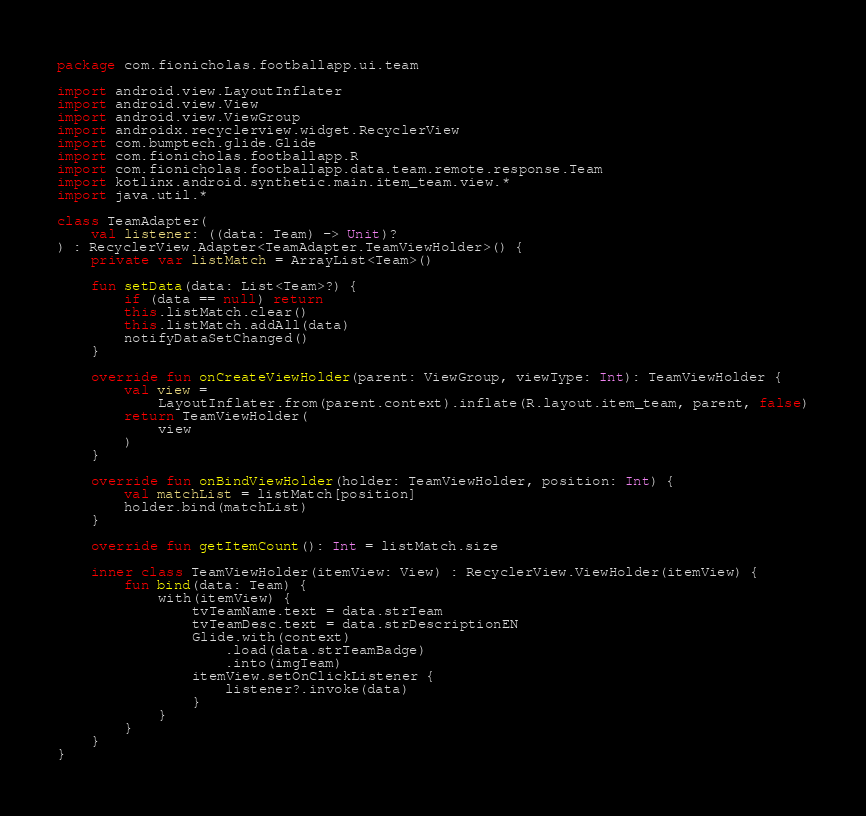Convert code to text. <code><loc_0><loc_0><loc_500><loc_500><_Kotlin_>package com.fionicholas.footballapp.ui.team

import android.view.LayoutInflater
import android.view.View
import android.view.ViewGroup
import androidx.recyclerview.widget.RecyclerView
import com.bumptech.glide.Glide
import com.fionicholas.footballapp.R
import com.fionicholas.footballapp.data.team.remote.response.Team
import kotlinx.android.synthetic.main.item_team.view.*
import java.util.*

class TeamAdapter(
    val listener: ((data: Team) -> Unit)?
) : RecyclerView.Adapter<TeamAdapter.TeamViewHolder>() {
    private var listMatch = ArrayList<Team>()

    fun setData(data: List<Team>?) {
        if (data == null) return
        this.listMatch.clear()
        this.listMatch.addAll(data)
        notifyDataSetChanged()
    }

    override fun onCreateViewHolder(parent: ViewGroup, viewType: Int): TeamViewHolder {
        val view =
            LayoutInflater.from(parent.context).inflate(R.layout.item_team, parent, false)
        return TeamViewHolder(
            view
        )
    }

    override fun onBindViewHolder(holder: TeamViewHolder, position: Int) {
        val matchList = listMatch[position]
        holder.bind(matchList)
    }

    override fun getItemCount(): Int = listMatch.size

    inner class TeamViewHolder(itemView: View) : RecyclerView.ViewHolder(itemView) {
        fun bind(data: Team) {
            with(itemView) {
                tvTeamName.text = data.strTeam
                tvTeamDesc.text = data.strDescriptionEN
                Glide.with(context)
                    .load(data.strTeamBadge)
                    .into(imgTeam)
                itemView.setOnClickListener {
                    listener?.invoke(data)
                }
            }
        }
    }
}</code> 